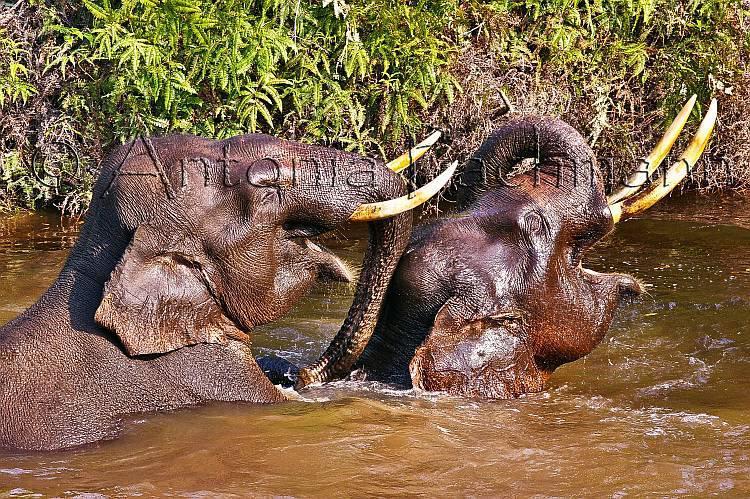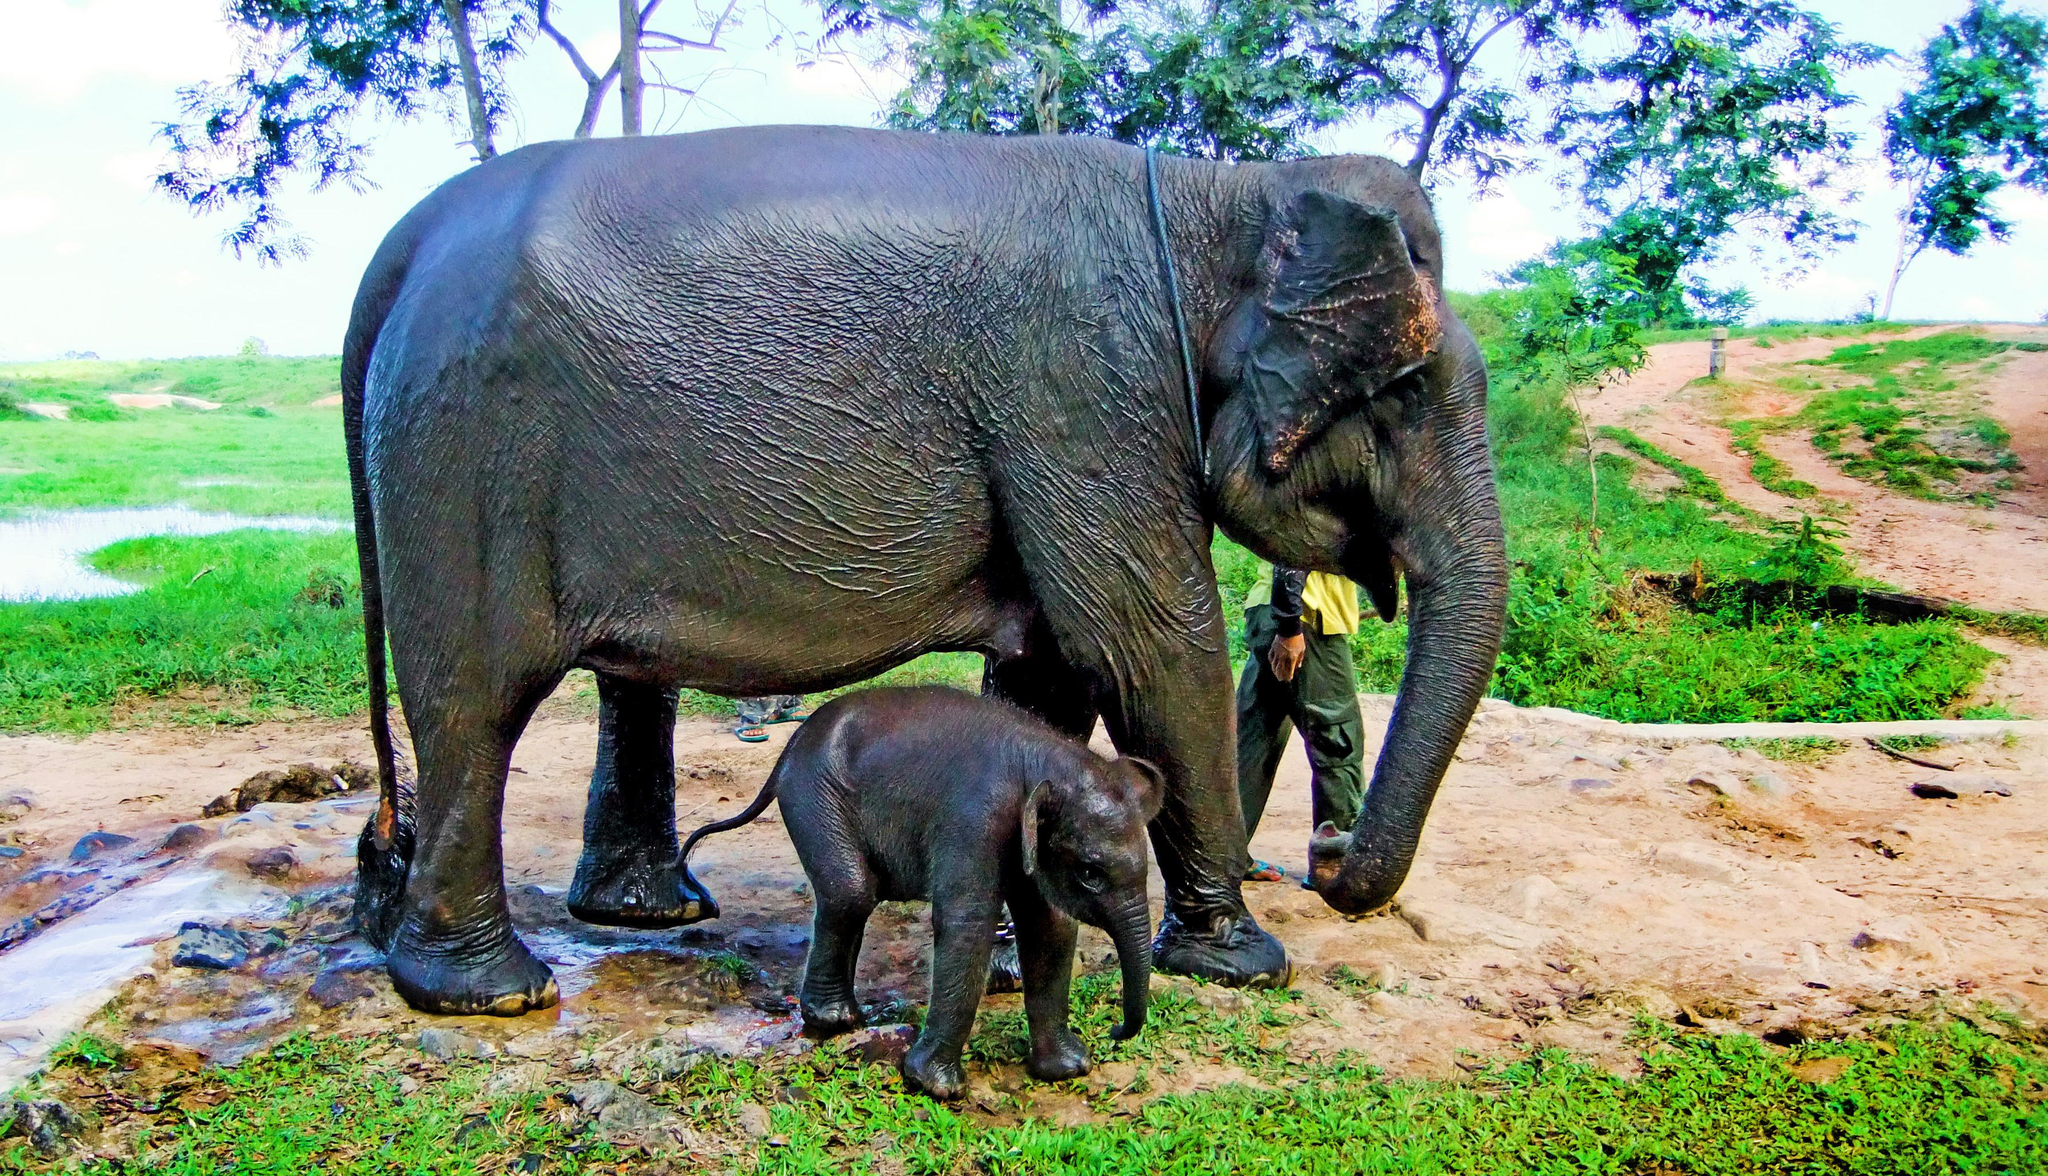The first image is the image on the left, the second image is the image on the right. For the images displayed, is the sentence "There are at leasts six elephants in one image." factually correct? Answer yes or no. No. The first image is the image on the left, the second image is the image on the right. Given the left and right images, does the statement "there are two elephants in the left side pic" hold true? Answer yes or no. Yes. 